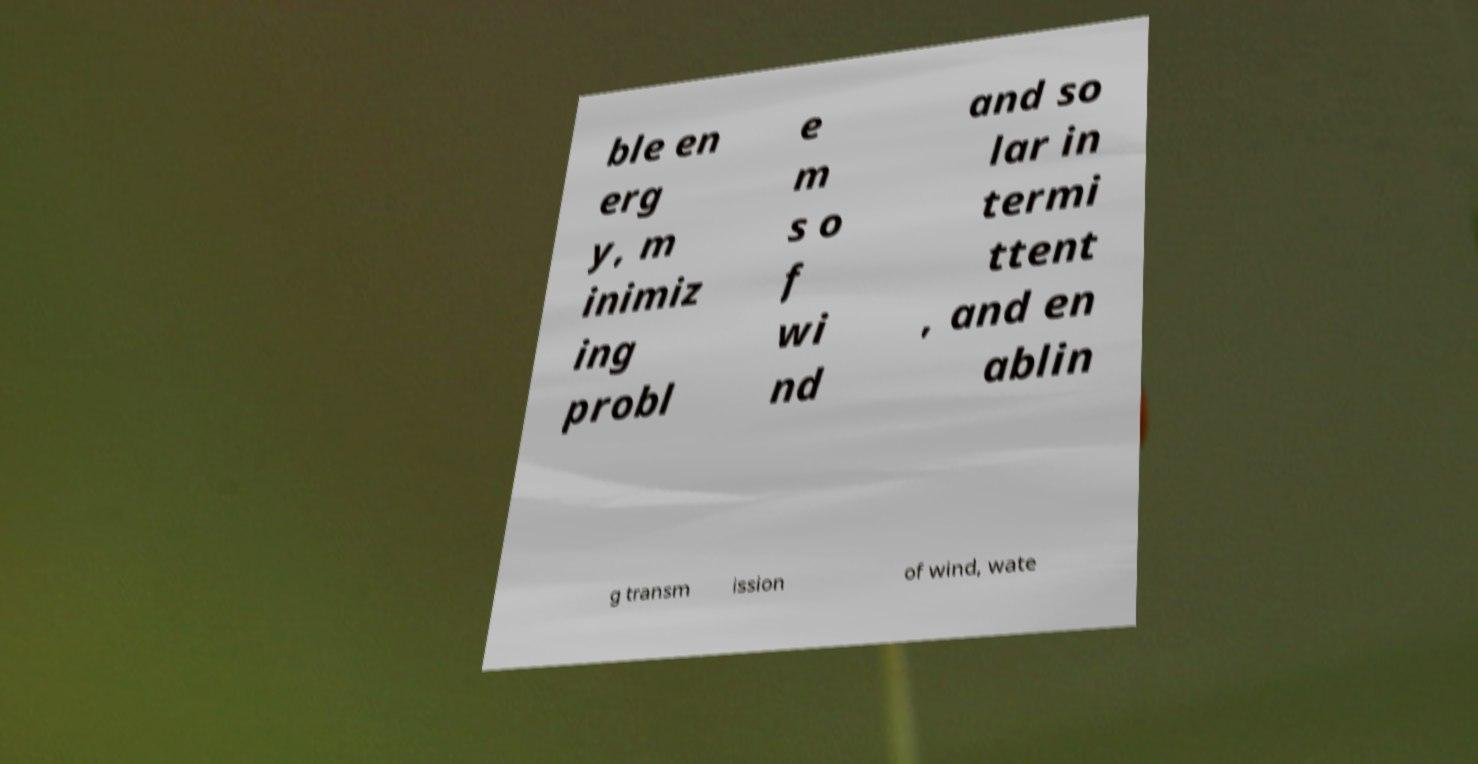Could you extract and type out the text from this image? ble en erg y, m inimiz ing probl e m s o f wi nd and so lar in termi ttent , and en ablin g transm ission of wind, wate 